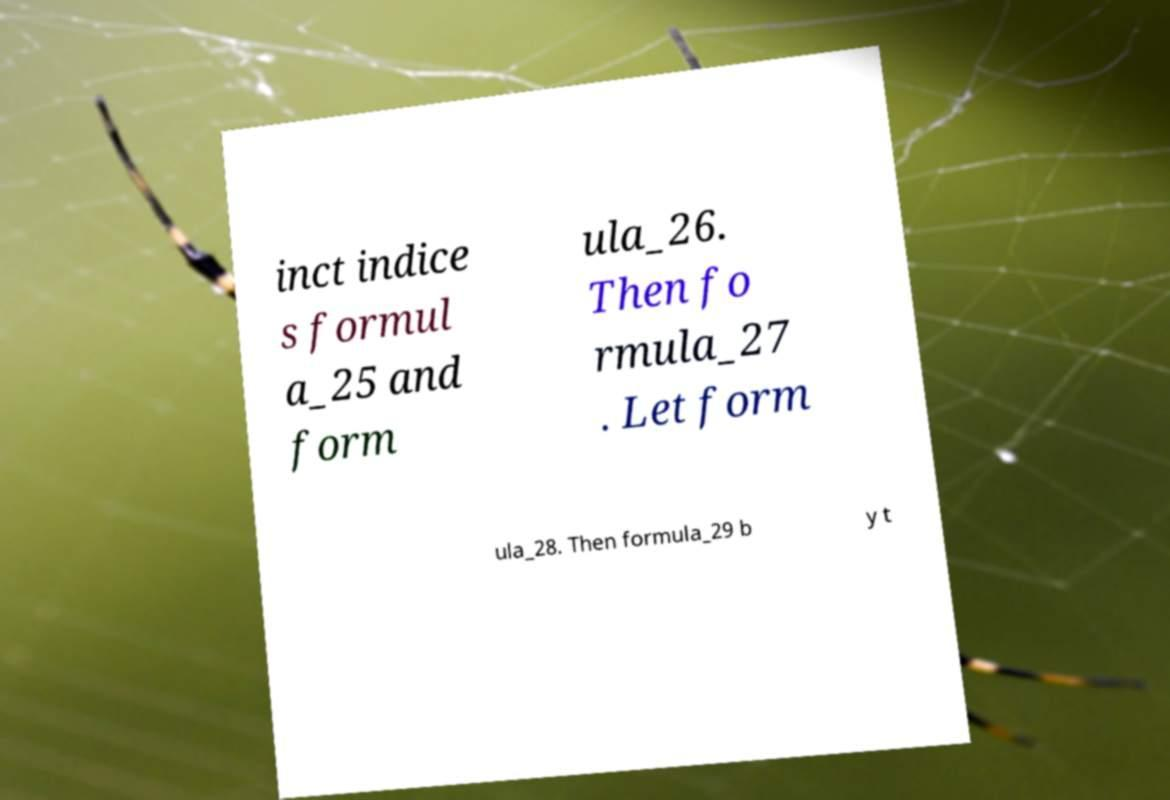For documentation purposes, I need the text within this image transcribed. Could you provide that? inct indice s formul a_25 and form ula_26. Then fo rmula_27 . Let form ula_28. Then formula_29 b y t 